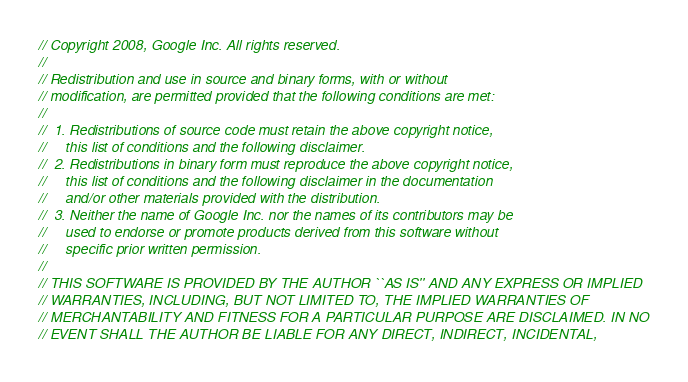<code> <loc_0><loc_0><loc_500><loc_500><_C++_>// Copyright 2008, Google Inc. All rights reserved.
//
// Redistribution and use in source and binary forms, with or without 
// modification, are permitted provided that the following conditions are met:
//
//  1. Redistributions of source code must retain the above copyright notice, 
//     this list of conditions and the following disclaimer.
//  2. Redistributions in binary form must reproduce the above copyright notice,
//     this list of conditions and the following disclaimer in the documentation
//     and/or other materials provided with the distribution.
//  3. Neither the name of Google Inc. nor the names of its contributors may be
//     used to endorse or promote products derived from this software without
//     specific prior written permission.
//
// THIS SOFTWARE IS PROVIDED BY THE AUTHOR ``AS IS'' AND ANY EXPRESS OR IMPLIED
// WARRANTIES, INCLUDING, BUT NOT LIMITED TO, THE IMPLIED WARRANTIES OF 
// MERCHANTABILITY AND FITNESS FOR A PARTICULAR PURPOSE ARE DISCLAIMED. IN NO
// EVENT SHALL THE AUTHOR BE LIABLE FOR ANY DIRECT, INDIRECT, INCIDENTAL, </code> 